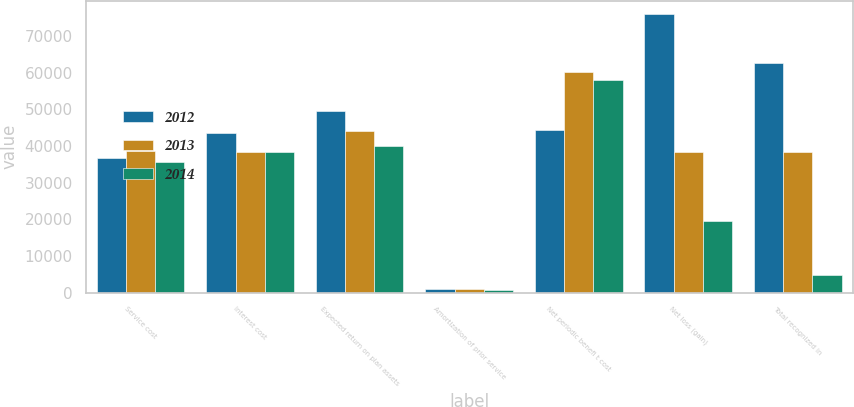Convert chart. <chart><loc_0><loc_0><loc_500><loc_500><stacked_bar_chart><ecel><fcel>Service cost<fcel>Interest cost<fcel>Expected return on plan assets<fcel>Amortization of prior service<fcel>Net periodic benefi t cost<fcel>Net loss (gain)<fcel>Total recognized in<nl><fcel>2012<fcel>36609<fcel>43613<fcel>49552<fcel>847<fcel>44298<fcel>75909<fcel>62724<nl><fcel>2013<fcel>38580<fcel>38243<fcel>44222<fcel>856<fcel>60273<fcel>38295.5<fcel>38295.5<nl><fcel>2014<fcel>35609<fcel>38348<fcel>40064<fcel>781<fcel>58141<fcel>19423<fcel>4825<nl></chart> 